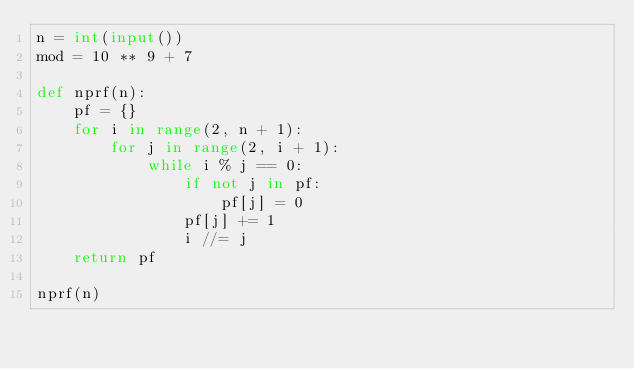<code> <loc_0><loc_0><loc_500><loc_500><_Python_>n = int(input())
mod = 10 ** 9 + 7

def nprf(n):
    pf = {}
    for i in range(2, n + 1):
        for j in range(2, i + 1):
            while i % j == 0:
                if not j in pf:
                    pf[j] = 0
                pf[j] += 1
                i //= j
    return pf

nprf(n)</code> 